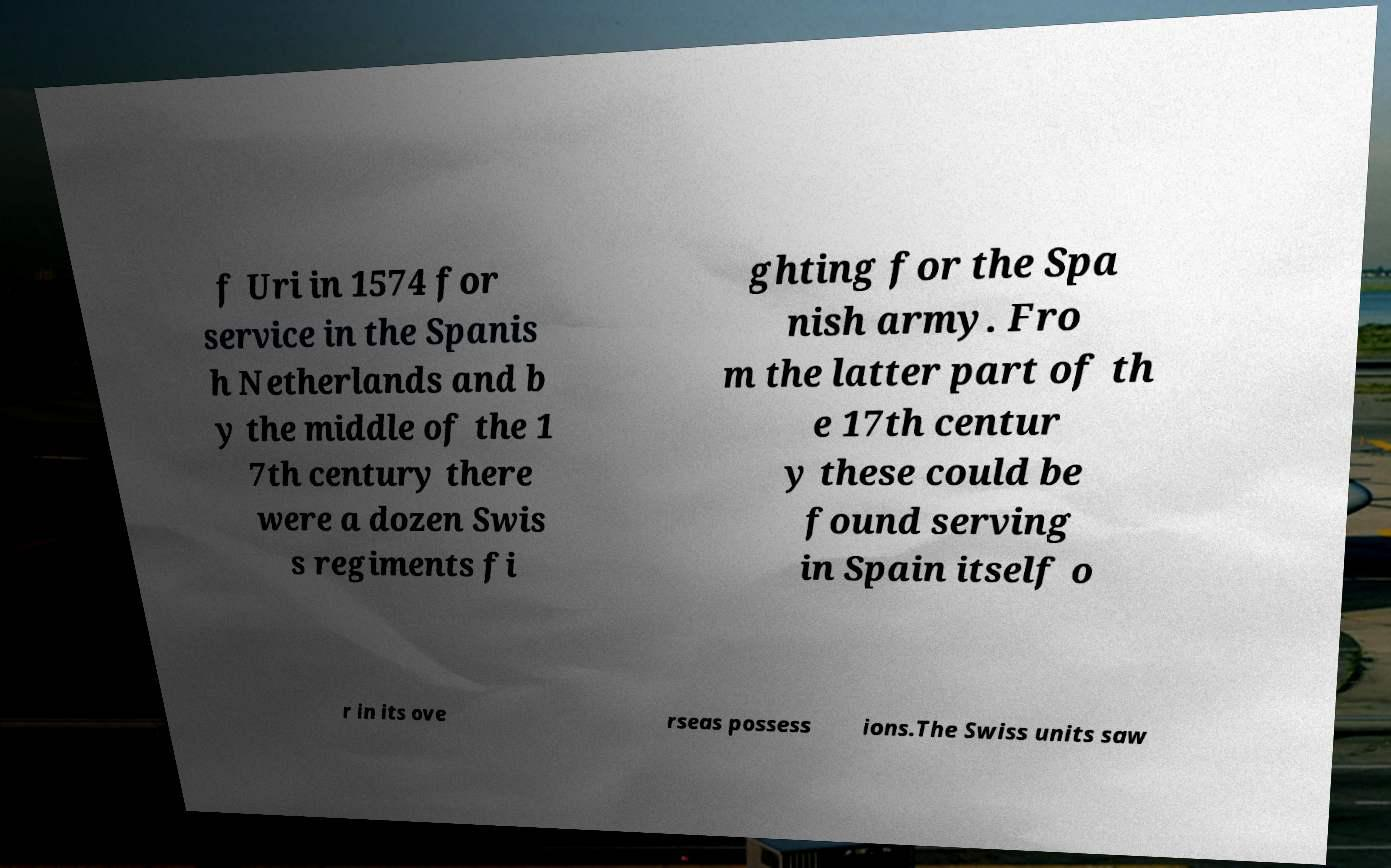I need the written content from this picture converted into text. Can you do that? f Uri in 1574 for service in the Spanis h Netherlands and b y the middle of the 1 7th century there were a dozen Swis s regiments fi ghting for the Spa nish army. Fro m the latter part of th e 17th centur y these could be found serving in Spain itself o r in its ove rseas possess ions.The Swiss units saw 